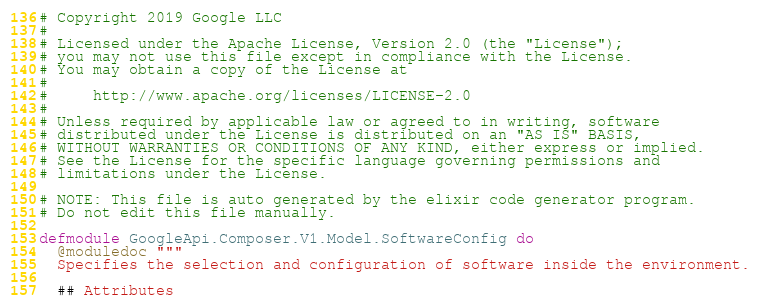<code> <loc_0><loc_0><loc_500><loc_500><_Elixir_># Copyright 2019 Google LLC
#
# Licensed under the Apache License, Version 2.0 (the "License");
# you may not use this file except in compliance with the License.
# You may obtain a copy of the License at
#
#     http://www.apache.org/licenses/LICENSE-2.0
#
# Unless required by applicable law or agreed to in writing, software
# distributed under the License is distributed on an "AS IS" BASIS,
# WITHOUT WARRANTIES OR CONDITIONS OF ANY KIND, either express or implied.
# See the License for the specific language governing permissions and
# limitations under the License.

# NOTE: This file is auto generated by the elixir code generator program.
# Do not edit this file manually.

defmodule GoogleApi.Composer.V1.Model.SoftwareConfig do
  @moduledoc """
  Specifies the selection and configuration of software inside the environment.

  ## Attributes
</code> 